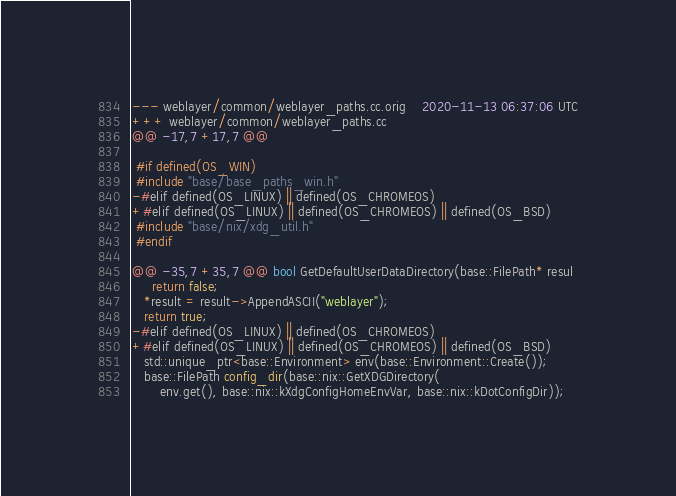Convert code to text. <code><loc_0><loc_0><loc_500><loc_500><_C++_>--- weblayer/common/weblayer_paths.cc.orig	2020-11-13 06:37:06 UTC
+++ weblayer/common/weblayer_paths.cc
@@ -17,7 +17,7 @@
 
 #if defined(OS_WIN)
 #include "base/base_paths_win.h"
-#elif defined(OS_LINUX) || defined(OS_CHROMEOS)
+#elif defined(OS_LINUX) || defined(OS_CHROMEOS) || defined(OS_BSD)
 #include "base/nix/xdg_util.h"
 #endif
 
@@ -35,7 +35,7 @@ bool GetDefaultUserDataDirectory(base::FilePath* resul
     return false;
   *result = result->AppendASCII("weblayer");
   return true;
-#elif defined(OS_LINUX) || defined(OS_CHROMEOS)
+#elif defined(OS_LINUX) || defined(OS_CHROMEOS) || defined(OS_BSD)
   std::unique_ptr<base::Environment> env(base::Environment::Create());
   base::FilePath config_dir(base::nix::GetXDGDirectory(
       env.get(), base::nix::kXdgConfigHomeEnvVar, base::nix::kDotConfigDir));
</code> 